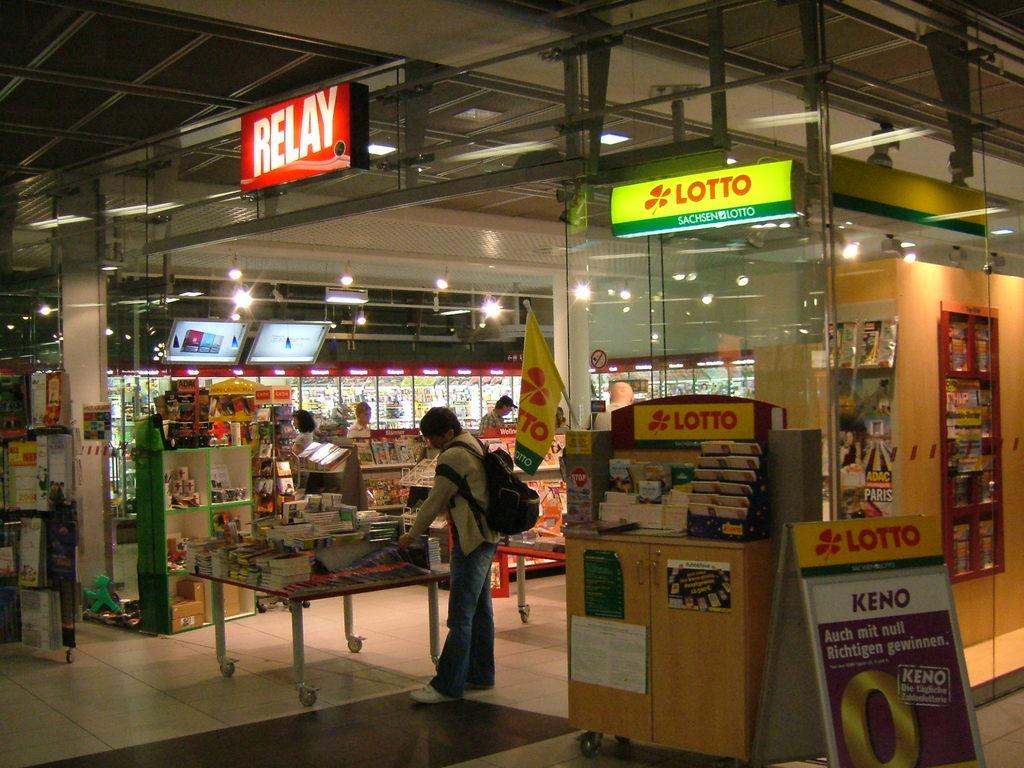Provide a one-sentence caption for the provided image. A store that sells something by the brand Lotto. 